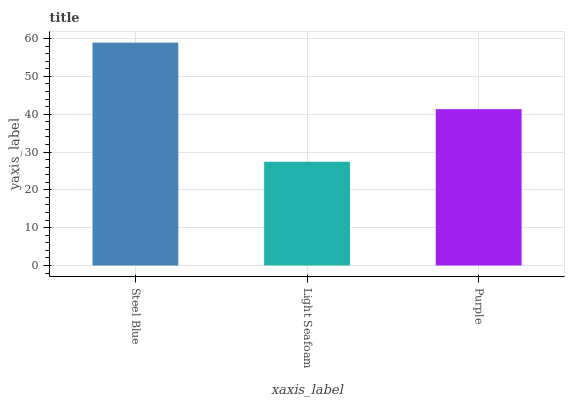Is Light Seafoam the minimum?
Answer yes or no. Yes. Is Steel Blue the maximum?
Answer yes or no. Yes. Is Purple the minimum?
Answer yes or no. No. Is Purple the maximum?
Answer yes or no. No. Is Purple greater than Light Seafoam?
Answer yes or no. Yes. Is Light Seafoam less than Purple?
Answer yes or no. Yes. Is Light Seafoam greater than Purple?
Answer yes or no. No. Is Purple less than Light Seafoam?
Answer yes or no. No. Is Purple the high median?
Answer yes or no. Yes. Is Purple the low median?
Answer yes or no. Yes. Is Light Seafoam the high median?
Answer yes or no. No. Is Light Seafoam the low median?
Answer yes or no. No. 